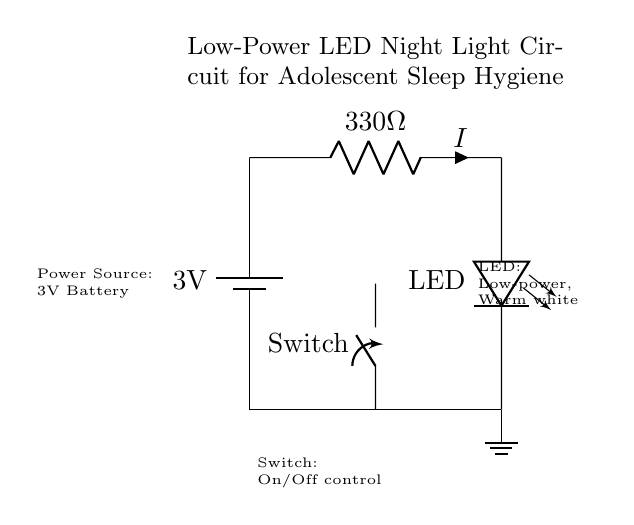What is the voltage of the power source? The voltage of the power source is directly indicated as 3V in the diagram, represented by the battery component.
Answer: 3V What is the resistance value in this circuit? The resistance value is stated as 330 ohms, shown next to the resistor symbol in the circuit.
Answer: 330 ohms What type of component is the night light based on? The night light uses an LED, as indicated by the specific label in the circuit, which highlights the type of light source.
Answer: LED What is the function of the switch in this circuit? The switch serves the purpose of controlling the current flow, allowing the light to be turned on or off, as outlined in the labeling of the switch.
Answer: On/Off control How does the current flow in this circuit when the switch is closed? When the switch is closed, the circuit is completed, allowing current to flow from the battery through the resistor to the LED, resulting in the LED illuminating.
Answer: Current flows through What impact does using a low-power LED have on energy consumption? The use of a low-power LED reduces energy consumption compared to traditional lighting, as it requires less voltage and current to operate while providing sufficient light for the night environment.
Answer: Low energy consumption What is the purpose of the resistor in this circuit? The resistor limits the current flowing through the LED to prevent it from drawing too much current, which could damage the LED; its value is chosen to ensure safe operation.
Answer: Current limit 